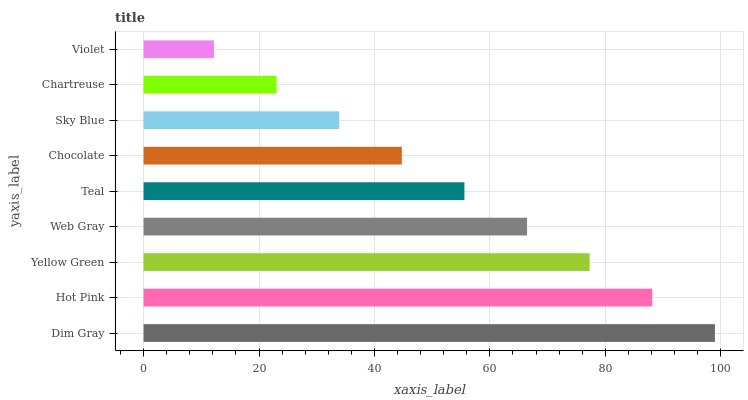Is Violet the minimum?
Answer yes or no. Yes. Is Dim Gray the maximum?
Answer yes or no. Yes. Is Hot Pink the minimum?
Answer yes or no. No. Is Hot Pink the maximum?
Answer yes or no. No. Is Dim Gray greater than Hot Pink?
Answer yes or no. Yes. Is Hot Pink less than Dim Gray?
Answer yes or no. Yes. Is Hot Pink greater than Dim Gray?
Answer yes or no. No. Is Dim Gray less than Hot Pink?
Answer yes or no. No. Is Teal the high median?
Answer yes or no. Yes. Is Teal the low median?
Answer yes or no. Yes. Is Chocolate the high median?
Answer yes or no. No. Is Violet the low median?
Answer yes or no. No. 